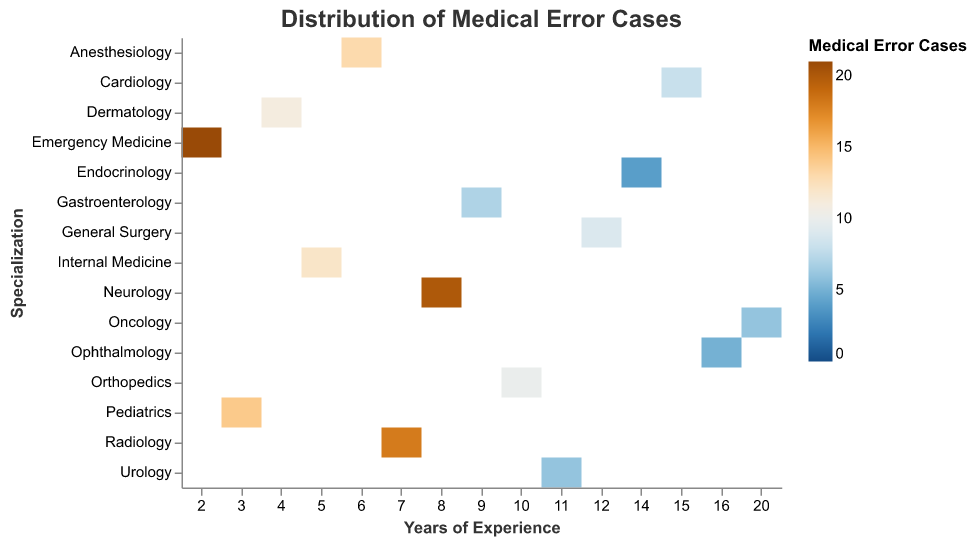What does the title of the heatmap convey? The title of the heatmap, "Distribution of Medical Error Cases," indicates that the chart visualizes the spread or allocation of medical error cases across doctors with different years of experience and specializations.
Answer: Distribution of Medical Error Cases Which doctor has the highest number of medical error cases and what is that number? Dr. James Harris in Emergency Medicine has the highest number of medical error cases with 21. This information can be found by looking at the piece of the heatmap with the most intense color, corresponding to the highest number of cases.
Answer: Dr. James Harris, 21 What is the specialization with the highest average number of medical error cases? Calculate the total number of medical error cases in each specialization and divide it by the number of doctors in that specialization. Emergency Medicine (21 cases, 1 doctor), Neurology (20 cases, 1 doctor), Radiology (18 cases, 1 doctor) have high values, but Emergency Medicine has the highest average of 21.
Answer: Emergency Medicine How many doctors have more than 10 years of experience and how do their medical error cases compare? Identify doctors with more than 10 years of experience: Dr. Samantha Miller, Dr. Linda Taylor, Dr. Susan Thomas, Dr. Barbara White, Dr. Jennifer Clark, Dr. Nancy Walker. Their medical error cases are 8, 6, 9, 5, 4, 6 respectively. Summing these numbers gives a total of 38 cases.
Answer: 6 doctors, 38 cases Which specializations have doctors with exactly 10 years of experience and how many error cases do they have? Identify doctors with exactly 10 years of experience: Dr. Michael Moore in Orthopedics. He has 10 medical error cases.
Answer: Orthopedics, 10 Compare the medical error cases between the two specializations with the least errors. Identify the specializations with the least errors: Endocrinology (4 cases) and Ophthalmology (5 cases). Compare the numbers directly: Endocrinology (4) has fewer cases than Ophthalmology (5).
Answer: Endocrinology < Ophthalmology What is the overall trend for medical error cases as years of experience increase? Observing the heatmap, it appears that medical error cases generally decrease as the years of experience increase. Doctors with fewer years of experience tend to have higher medical error cases, and those with more years have fewer error cases.
Answer: Decreasing trend For Internal Medicine, who is the practicing doctor and what is the number of medical error cases? Look for the Internal Medicine specialization on the heatmap, identifying Dr. John Smith as the practicing doctor with 12 medical error cases.
Answer: Dr. John Smith, 12 Which specialization has the most consistent number of medical error cases among its doctors? By comparing the cases within specializations like Oncology (6 cases), Neurology (20 cases), etc., we find that Oncology appears consistent with one doctor reporting 6 cases, which is fairly low and tightly clustered in value.
Answer: Oncology What is the total number of medical error cases for doctors with less than 5 years of experience? Identify the doctors with less than 5 years of experience: Dr. Karen Wilson (14 cases), Dr. Robert Martin (11 cases), Dr. James Harris (21 cases). Summing these numbers gives 14 + 11 + 21 = 46.
Answer: 46 